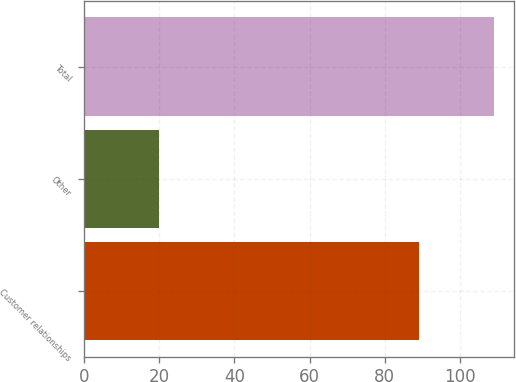Convert chart. <chart><loc_0><loc_0><loc_500><loc_500><bar_chart><fcel>Customer relationships<fcel>Other<fcel>Total<nl><fcel>89.1<fcel>19.9<fcel>109<nl></chart> 